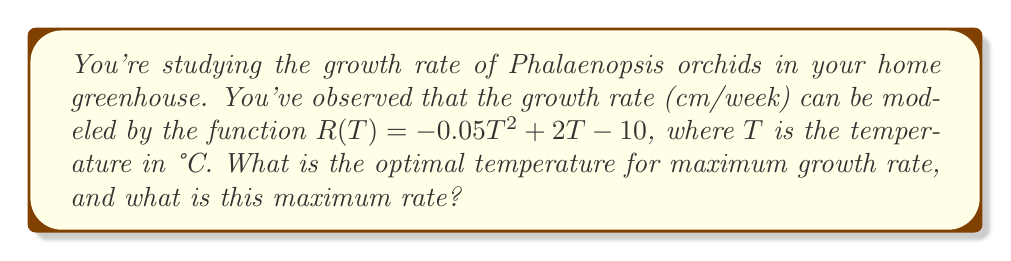Solve this math problem. To solve this problem, we'll follow these steps:

1) The growth rate function is quadratic: $R(T) = -0.05T^2 + 2T - 10$

2) To find the maximum point of a quadratic function, we need to find the vertex. For a quadratic function in the form $f(x) = ax^2 + bx + c$, the x-coordinate of the vertex is given by $x = -\frac{b}{2a}$

3) In our case, $a = -0.05$, $b = 2$, and $c = -10$

4) Let's calculate the optimal temperature:

   $T_{optimal} = -\frac{b}{2a} = -\frac{2}{2(-0.05)} = -\frac{2}{-0.1} = 20°C$

5) To find the maximum growth rate, we substitute this optimal temperature back into our original function:

   $R(20) = -0.05(20)^2 + 2(20) - 10$
          $= -0.05(400) + 40 - 10$
          $= -20 + 40 - 10$
          $= 10$ cm/week

Therefore, the optimal temperature is 20°C, and the maximum growth rate is 10 cm/week.
Answer: Optimal temperature: 20°C; Maximum growth rate: 10 cm/week 